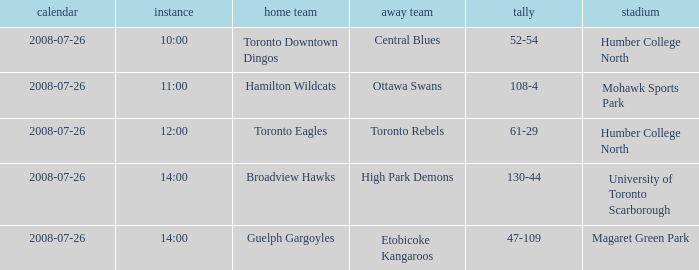Who has the Home Score of 52-54? Toronto Downtown Dingos. 